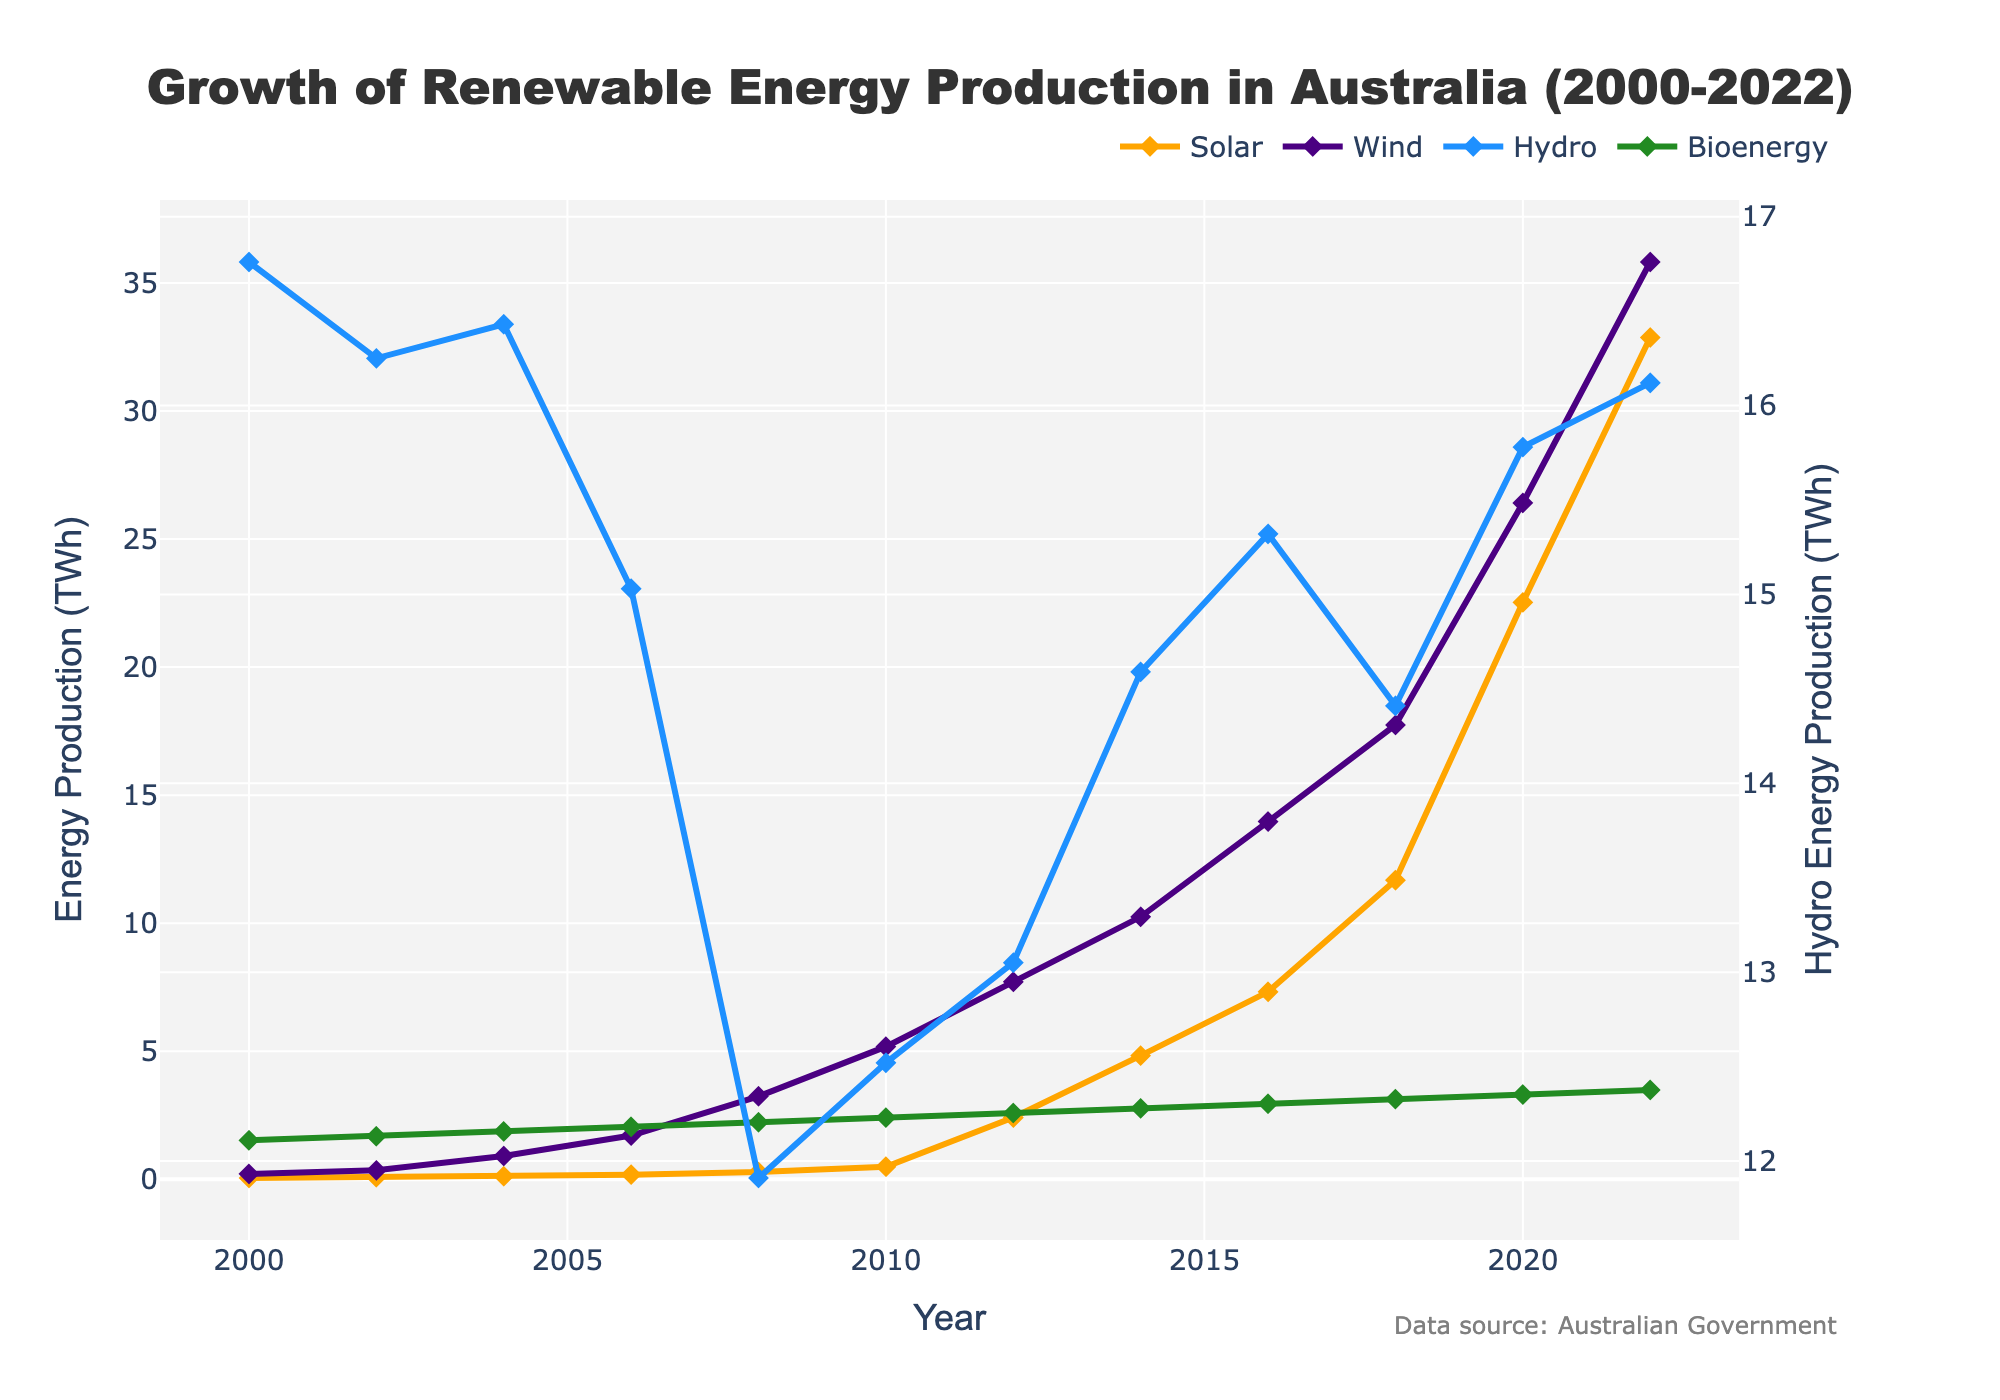How has solar energy production changed from 2000 to 2022? Solar energy production increased from 0.05 TWh in 2000 to 32.87 TWh in 2022. By examining the line corresponding to solar energy, we can see that it follows an upward trajectory.
Answer: It increased from 0.05 TWh to 32.87 TWh Which energy source showed the highest growth rate between 2010 and 2022? By comparing the lines for each energy source from 2010 to 2022, we observe that solar energy experienced the sharpest increase, from 0.49 TWh to 32.87 TWh, indicating the highest growth rate.
Answer: Solar energy What is the total renewable energy production (sum of all sources) for the year 2016? To find the total renewable energy production for 2016, sum up the energy production from each source: Solar (7.32 TWh) + Wind (13.97 TWh) + Hydro (15.32 TWh) + Bioenergy (2.95 TWh).
Answer: 39.56 TWh In which year did solar energy production first surpass 10 TWh? By inspecting the line for solar energy, we see that it surpassed 10 TWh in 2018.
Answer: 2018 How did hydro energy production change over the years? Hydro energy production fluctuated, starting from 16.76 TWh in 2000 and experiencing a dip around 2008, before recovering and stabilizing around 16.12 TWh in 2022.
Answer: It fluctuated but remained relatively stable Which energy source had the least production in the year 2022? By looking at the endpoints of each line on the graph for the year 2022, we see that Bioenergy had the least production at 3.49 TWh.
Answer: Bioenergy Compare the production levels of wind and solar energy in 2020. Which was higher, and by how much? Wind energy production in 2020 was 26.41 TWh, while solar energy production was 22.53 TWh. To find the difference, subtract 22.53 TWh from 26.41 TWh.
Answer: Wind energy was higher by 3.88 TWh What were the approximate growth rates of solar and wind energy between 2000 and 2022? The growth rates can be estimated by dividing the final production values by the initial values and considering the time period. For solar energy: 32.87 TWh / 0.05 TWh ≈ 657.4. For wind energy, 35.82 TWh / 0.21 TWh ≈ 170.6. Both were large, but solar energy's rate is more significant.
Answer: Solar: ≈657.4, Wind: ≈170.6 Which year saw the highest increase in wind energy production compared to the previous year? By examining the slopes of the wind energy line, the steepest increase appears around 2012-2014. Specifically, from 2012 (7.71 TWh) to 2014 (10.25 TWh) is the highest increase, which is 2.54 TWh.
Answer: 2012 to 2014, with a 2.54 TWh increase 